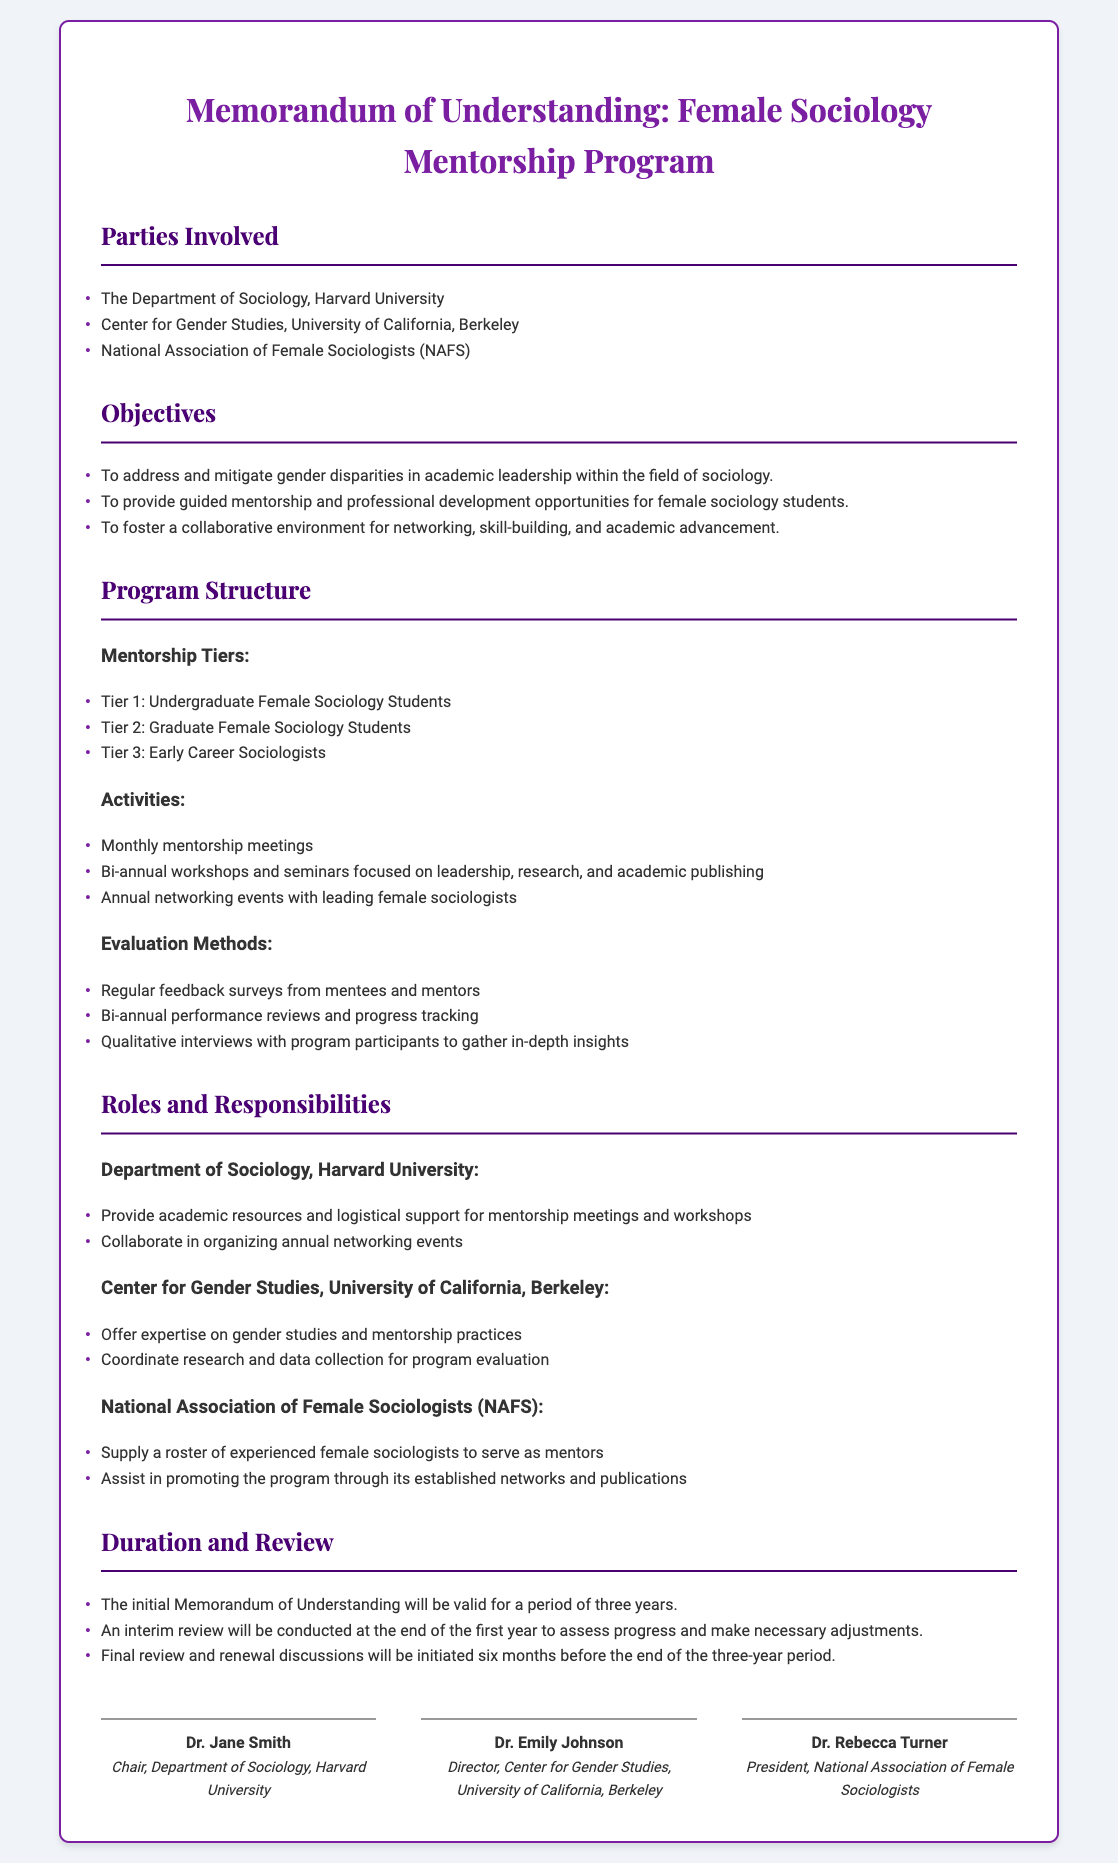What are the parties involved? The parties involved are listed under the "Parties Involved" section of the document.
Answer: The Department of Sociology, Harvard University; Center for Gender Studies, University of California, Berkeley; National Association of Female Sociologists (NAFS) What is the duration of the Memorandum of Understanding? The duration is specified in the "Duration and Review" section of the document.
Answer: Three years How many mentorship tiers are there? The number of mentorship tiers is found in the "Mentorship Tiers" sub-section under "Program Structure."
Answer: Three What activities will be conducted under the program? The activities are detailed in the "Activities" sub-section under "Program Structure."
Answer: Monthly mentorship meetings; Bi-annual workshops and seminars focused on leadership, research, and academic publishing; Annual networking events with leading female sociologists Who is the Chair of the Department of Sociology at Harvard University? The name of the Chair is listed under the signatures at the end of the document.
Answer: Dr. Jane Smith What is one responsibility of the Center for Gender Studies, UC Berkeley? The responsibilities are itemized in the "Roles and Responsibilities" section of the document.
Answer: Offer expertise on gender studies and mentorship practices What type of feedback will be collected for evaluation? The methods of evaluation are outlined in the "Evaluation Methods" section.
Answer: Regular feedback surveys from mentees and mentors What will happen at the end of the first year? Information regarding reviews is found in the "Duration and Review" section.
Answer: An interim review will be conducted to assess progress and make necessary adjustments 